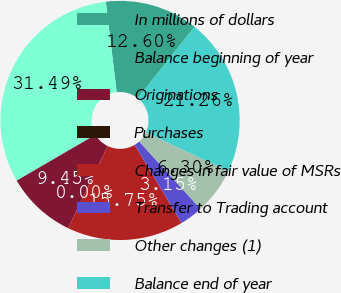<chart> <loc_0><loc_0><loc_500><loc_500><pie_chart><fcel>In millions of dollars<fcel>Balance beginning of year<fcel>Originations<fcel>Purchases<fcel>Changes in fair value of MSRs<fcel>Transfer to Trading account<fcel>Other changes (1)<fcel>Balance end of year<nl><fcel>12.6%<fcel>31.49%<fcel>9.45%<fcel>0.0%<fcel>15.75%<fcel>3.15%<fcel>6.3%<fcel>21.26%<nl></chart> 